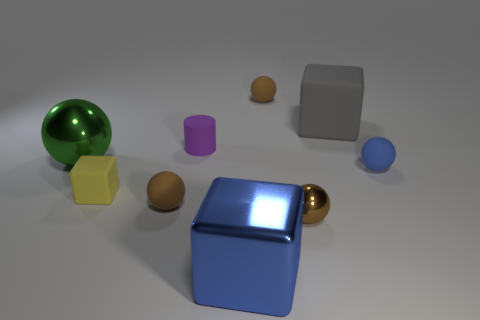Subtract all green cylinders. How many brown balls are left? 3 Subtract all tiny brown shiny balls. How many balls are left? 4 Subtract all blue balls. How many balls are left? 4 Subtract all gray spheres. Subtract all blue blocks. How many spheres are left? 5 Subtract all cylinders. How many objects are left? 8 Add 6 big balls. How many big balls exist? 7 Subtract 0 cyan spheres. How many objects are left? 9 Subtract all blue matte spheres. Subtract all gray rubber things. How many objects are left? 7 Add 2 small balls. How many small balls are left? 6 